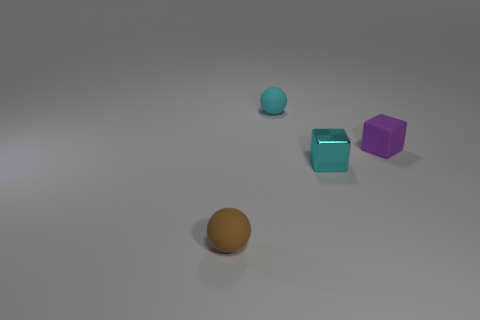Subtract 1 spheres. How many spheres are left? 1 Add 2 tiny rubber things. How many objects exist? 6 Subtract 0 green cubes. How many objects are left? 4 Subtract all cyan spheres. Subtract all green blocks. How many spheres are left? 1 Subtract all red cylinders. How many purple blocks are left? 1 Subtract all small rubber balls. Subtract all small brown objects. How many objects are left? 1 Add 4 cyan matte spheres. How many cyan matte spheres are left? 5 Add 1 brown rubber balls. How many brown rubber balls exist? 2 